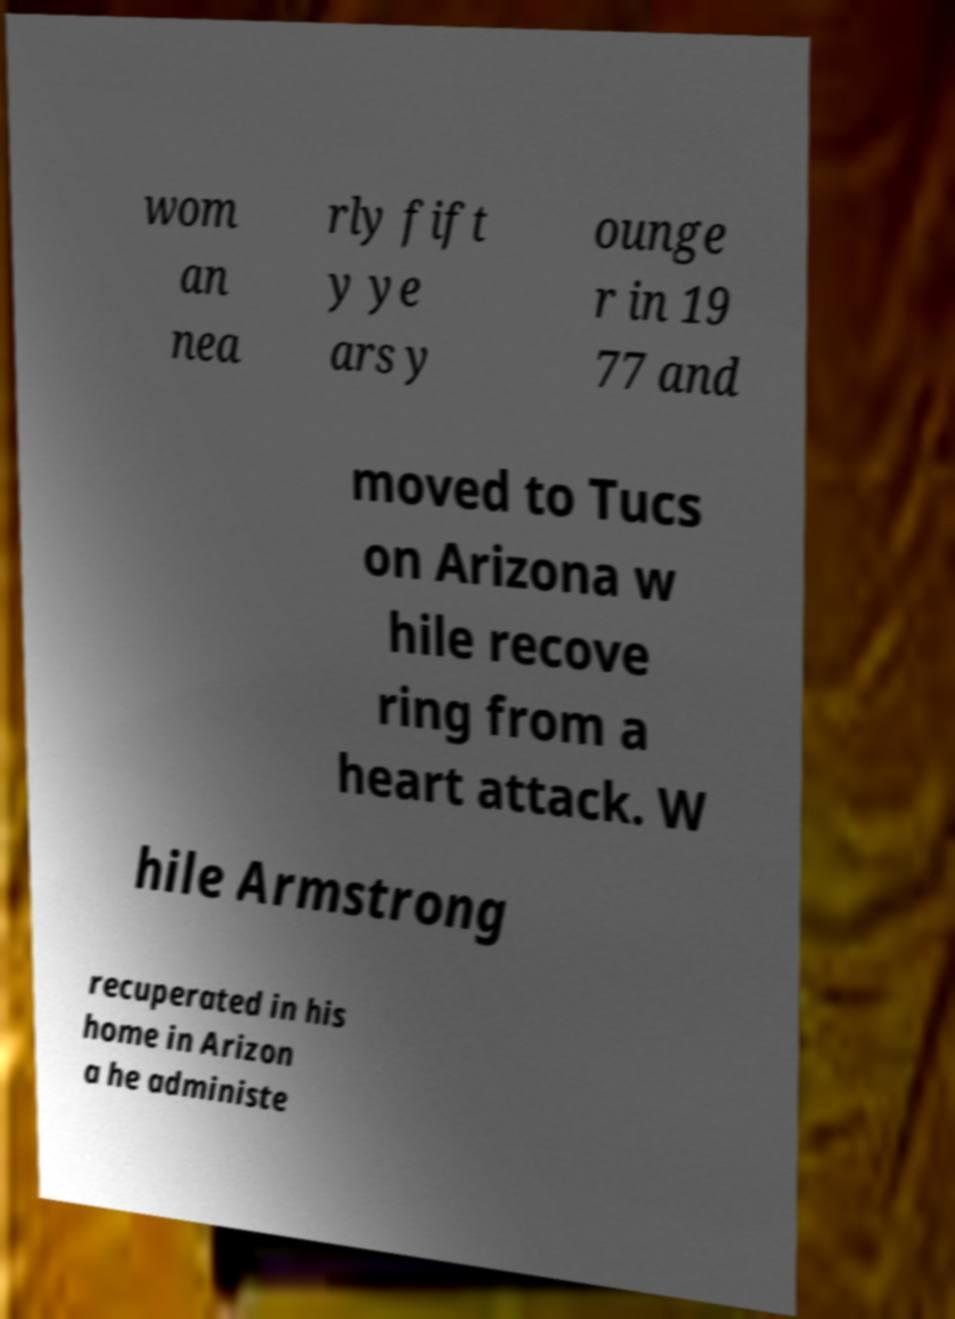There's text embedded in this image that I need extracted. Can you transcribe it verbatim? wom an nea rly fift y ye ars y ounge r in 19 77 and moved to Tucs on Arizona w hile recove ring from a heart attack. W hile Armstrong recuperated in his home in Arizon a he administe 